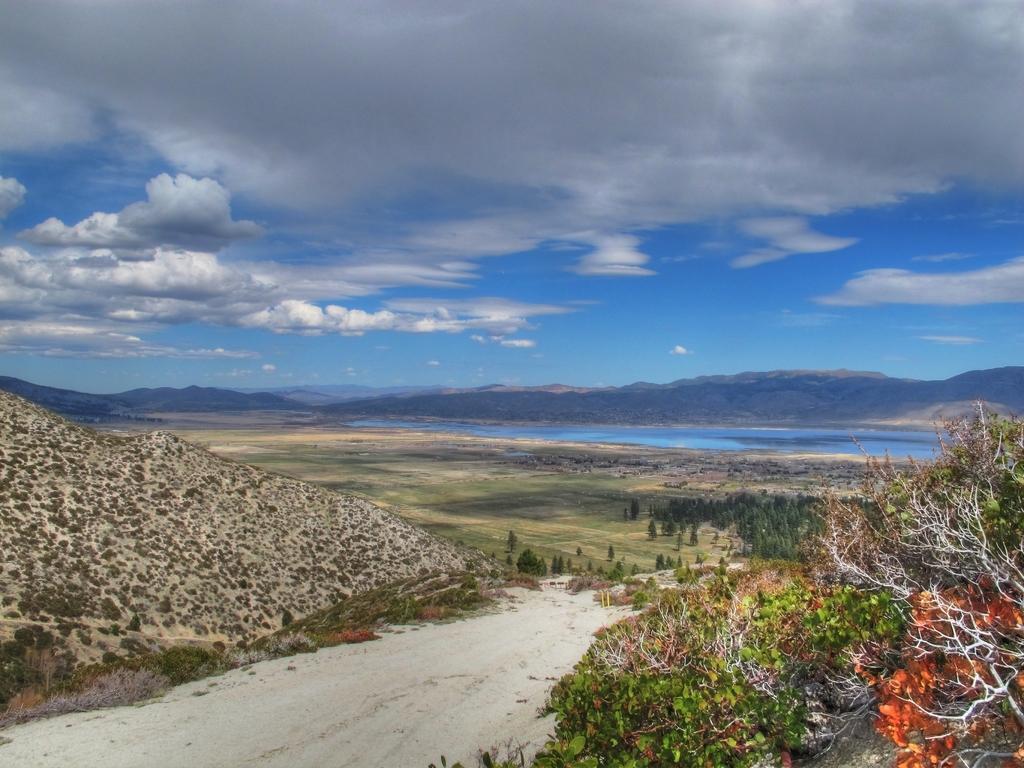In one or two sentences, can you explain what this image depicts? In this image I can see few mountains,trees and water. The sky is in blue and white color. 